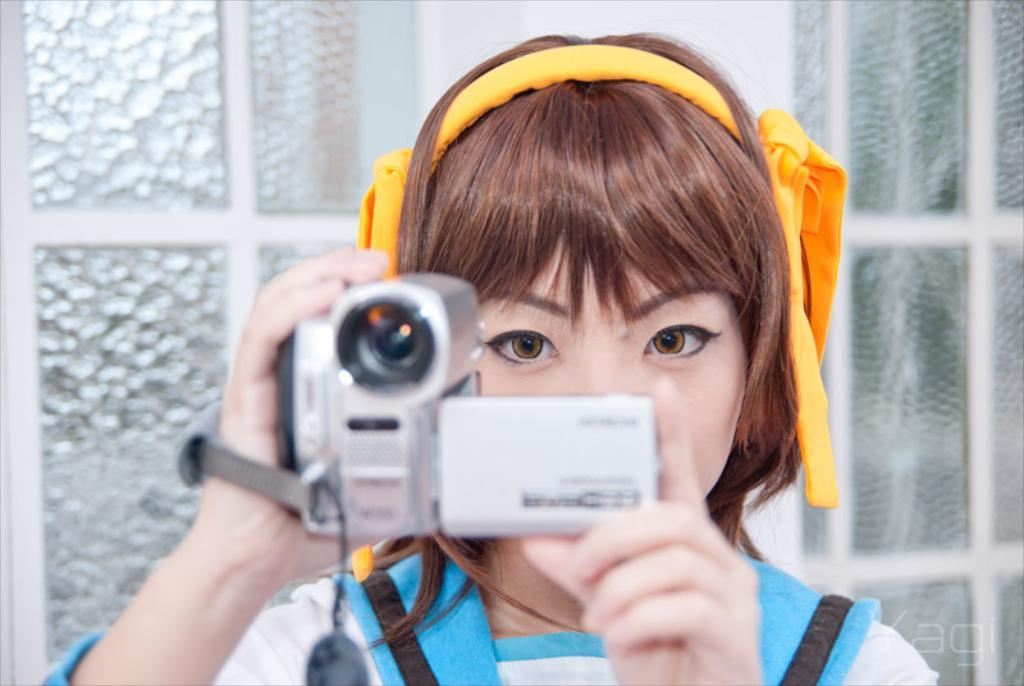Who is the main subject in the image? There is a girl in the image. What is the girl holding in her hand? The girl is holding a camera in her hand. What can be seen in the background of the image? There are windows with glass visible in the background. Where was the image taken? The image is taken inside a house. What type of fang can be seen in the image? There is no fang present in the image. What kind of furniture is visible in the image? The provided facts do not mention any furniture in the image. 